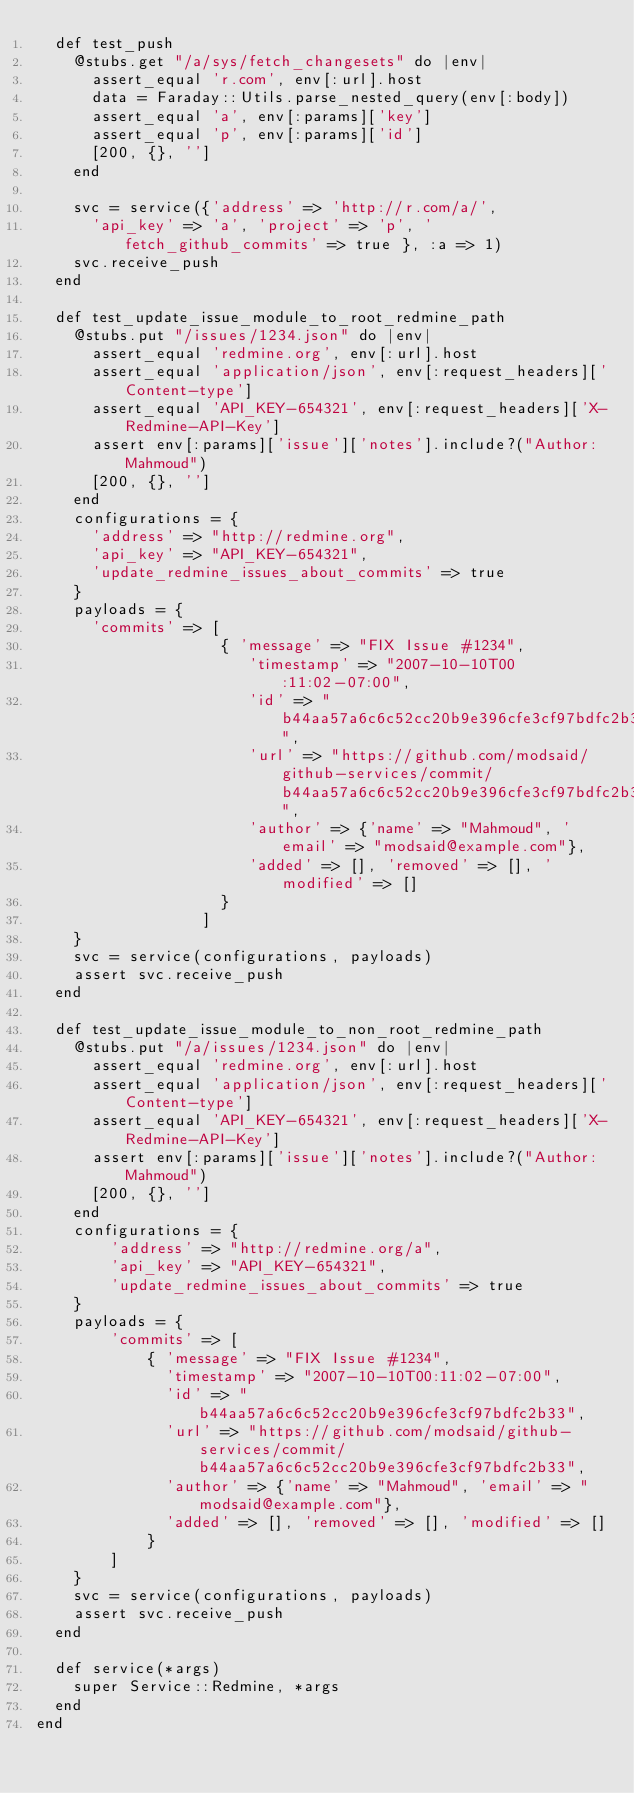Convert code to text. <code><loc_0><loc_0><loc_500><loc_500><_Ruby_>  def test_push
    @stubs.get "/a/sys/fetch_changesets" do |env|
      assert_equal 'r.com', env[:url].host
      data = Faraday::Utils.parse_nested_query(env[:body])
      assert_equal 'a', env[:params]['key']
      assert_equal 'p', env[:params]['id']
      [200, {}, '']
    end

    svc = service({'address' => 'http://r.com/a/',
      'api_key' => 'a', 'project' => 'p', 'fetch_github_commits' => true }, :a => 1)
    svc.receive_push
  end

  def test_update_issue_module_to_root_redmine_path
    @stubs.put "/issues/1234.json" do |env|
      assert_equal 'redmine.org', env[:url].host
      assert_equal 'application/json', env[:request_headers]['Content-type']
      assert_equal 'API_KEY-654321', env[:request_headers]['X-Redmine-API-Key']
      assert env[:params]['issue']['notes'].include?("Author: Mahmoud")
      [200, {}, '']
    end
    configurations = {
      'address' => "http://redmine.org", 
      'api_key' => "API_KEY-654321",
      'update_redmine_issues_about_commits' => true
    }
    payloads = {
      'commits' => [ 
                    { 'message' => "FIX Issue #1234", 
                       'timestamp' => "2007-10-10T00:11:02-07:00", 
                       'id' => "b44aa57a6c6c52cc20b9e396cfe3cf97bdfc2b33", 
                       'url' => "https://github.com/modsaid/github-services/commit/b44aa57a6c6c52cc20b9e396cfe3cf97bdfc2b33", 
                       'author' => {'name' => "Mahmoud", 'email' => "modsaid@example.com"}, 
                       'added' => [], 'removed' => [], 'modified' => []
                    }
                  ]
    }
    svc = service(configurations, payloads)
    assert svc.receive_push
  end

  def test_update_issue_module_to_non_root_redmine_path
    @stubs.put "/a/issues/1234.json" do |env|
      assert_equal 'redmine.org', env[:url].host
      assert_equal 'application/json', env[:request_headers]['Content-type']
      assert_equal 'API_KEY-654321', env[:request_headers]['X-Redmine-API-Key']
      assert env[:params]['issue']['notes'].include?("Author: Mahmoud")
      [200, {}, '']
    end
    configurations = {
        'address' => "http://redmine.org/a",
        'api_key' => "API_KEY-654321",
        'update_redmine_issues_about_commits' => true
    }
    payloads = {
        'commits' => [
            { 'message' => "FIX Issue #1234",
              'timestamp' => "2007-10-10T00:11:02-07:00",
              'id' => "b44aa57a6c6c52cc20b9e396cfe3cf97bdfc2b33",
              'url' => "https://github.com/modsaid/github-services/commit/b44aa57a6c6c52cc20b9e396cfe3cf97bdfc2b33",
              'author' => {'name' => "Mahmoud", 'email' => "modsaid@example.com"},
              'added' => [], 'removed' => [], 'modified' => []
            }
        ]
    }
    svc = service(configurations, payloads)
    assert svc.receive_push
  end

  def service(*args)
    super Service::Redmine, *args
  end
end

</code> 